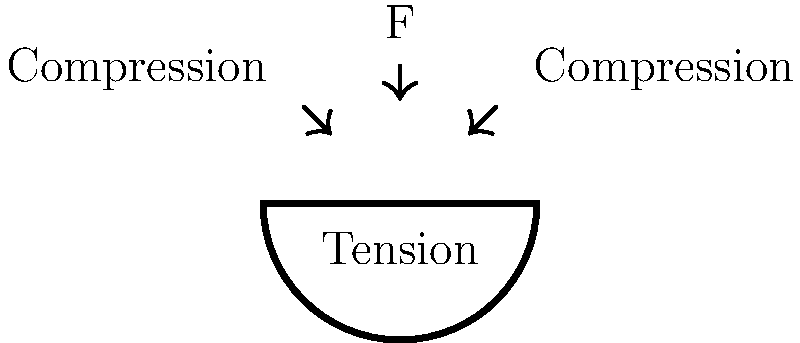In comparing the structural integrity of an Orthodox church dome to a Buddhist stupa, which force is most critical for the dome's stability, and how does it differ from the primary structural concern in a stupa? To understand the structural differences between an Orthodox church dome and a Buddhist stupa, let's examine the forces at play:

1. Orthodox church dome:
   a. The dome is subject to downward force (F) due to gravity.
   b. This force is distributed along the curved surface of the dome.
   c. The dome's shape converts the vertical force into lateral forces.
   d. These lateral forces result in compression along the sides of the dome.
   e. At the base of the dome, there's an outward horizontal force called thrust.
   f. This thrust must be counteracted to prevent the dome from collapsing outward.
   g. The walls or buttresses of the church provide this counterforce through tension.

2. Buddhist stupa:
   a. A stupa is typically a solid, mound-like structure.
   b. Its primary structural concern is compression from its own weight.
   c. The wide base of a stupa helps distribute this compressive force.
   d. There's minimal lateral thrust in a stupa due to its solid nature.

3. Key difference:
   a. The dome relies on a balance of compression and tension forces.
   b. The stupa primarily deals with compressive forces.

4. Critical force for dome stability:
   a. The outward thrust at the base of the dome is the most critical force.
   b. If not properly counteracted, this force can cause the dome to collapse.
   c. The tension in the supporting structure is crucial for stability.

Therefore, the most critical force for the dome's stability is the outward thrust at its base, which must be counteracted by tension in the supporting structure. This differs from a stupa, where the primary concern is managing compressive forces throughout its solid structure.
Answer: Outward thrust counteracted by tension 